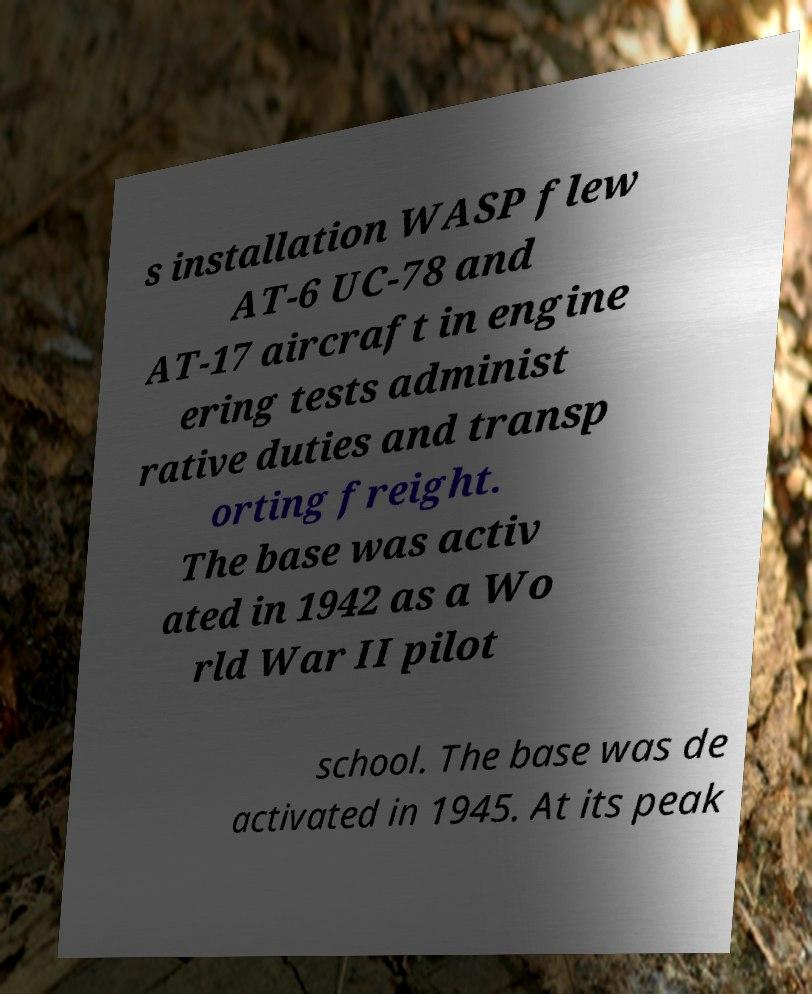For documentation purposes, I need the text within this image transcribed. Could you provide that? s installation WASP flew AT-6 UC-78 and AT-17 aircraft in engine ering tests administ rative duties and transp orting freight. The base was activ ated in 1942 as a Wo rld War II pilot school. The base was de activated in 1945. At its peak 